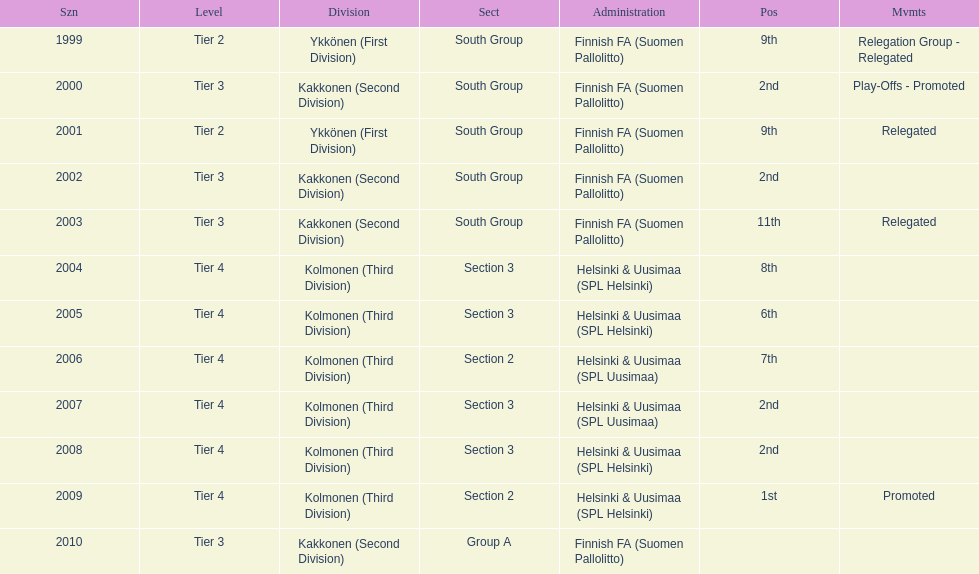How many times has this team been relegated? 3. 